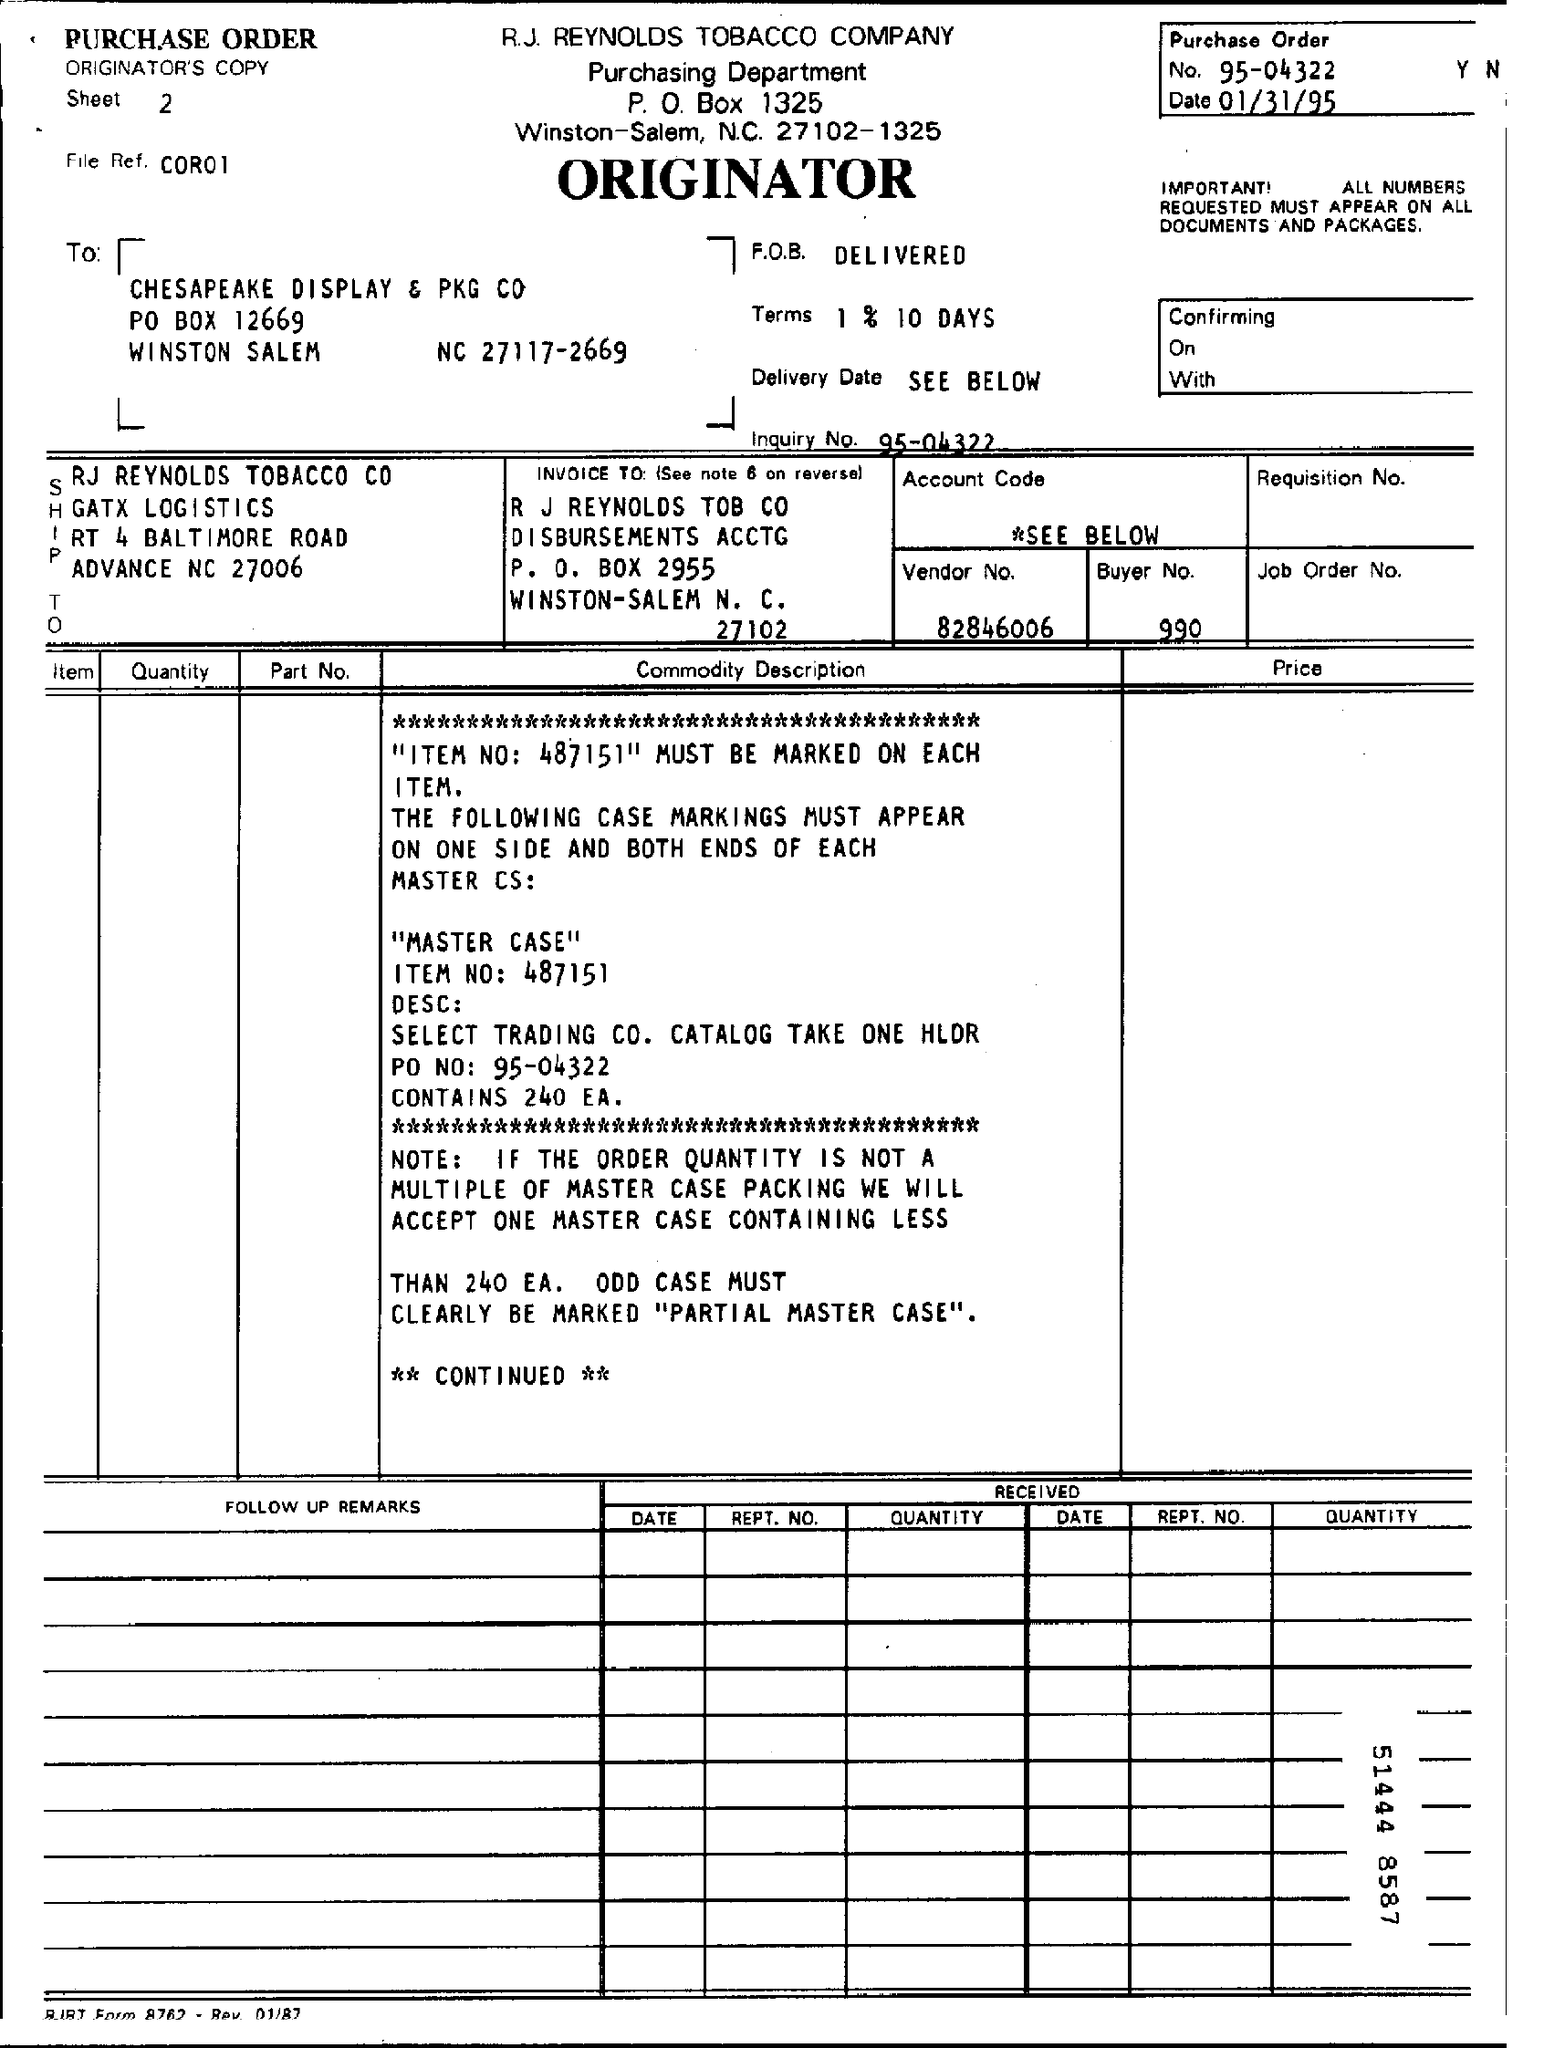What is the Purchase Order No.?
Provide a succinct answer. 95-04322. What is the Purchase Order date?
Give a very brief answer. 01/31/95. What is the Vendor No.?
Make the answer very short. 82846006. What is the Buyer No.?
Your answer should be very brief. 990. What is the Inquiry No.?
Provide a short and direct response. 95-04322. What is the File Ref.?
Make the answer very short. C0R01. 